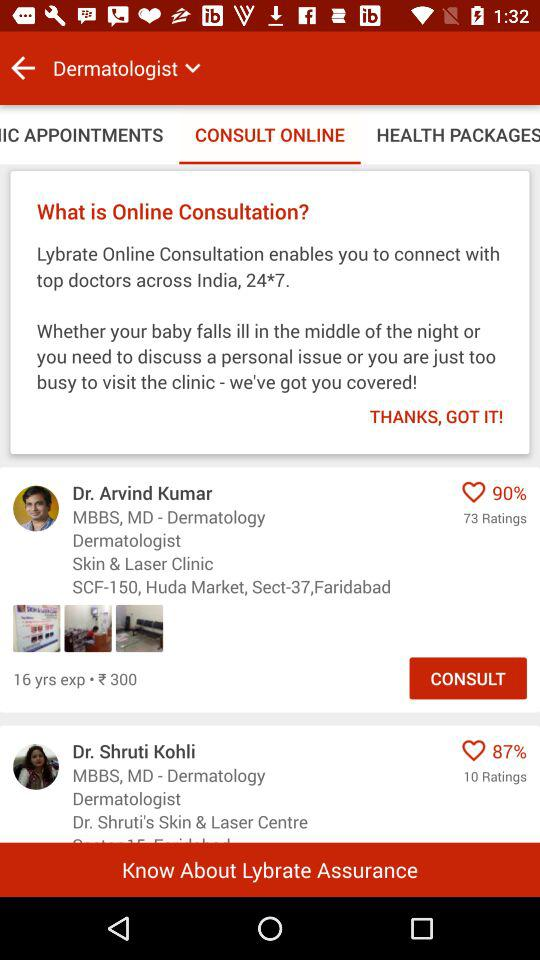Which tab is selected? The selected tab is "CONSULT ONLINE". 